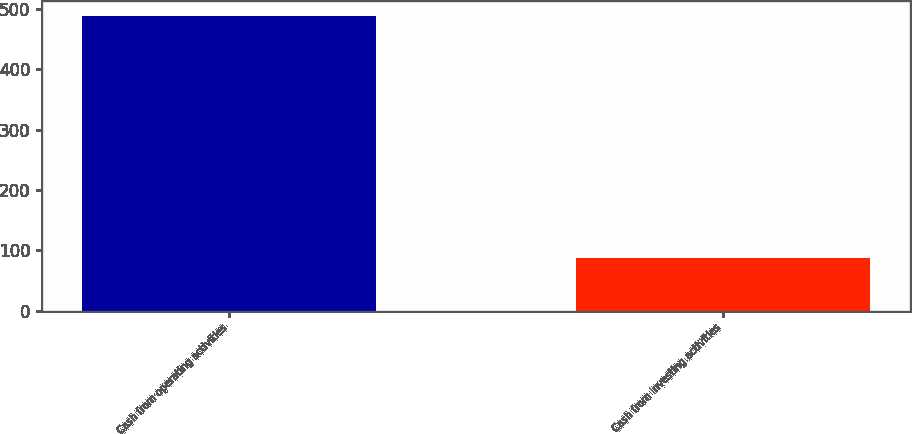Convert chart. <chart><loc_0><loc_0><loc_500><loc_500><bar_chart><fcel>Cash from operating activities<fcel>Cash from investing activities<nl><fcel>489<fcel>88<nl></chart> 